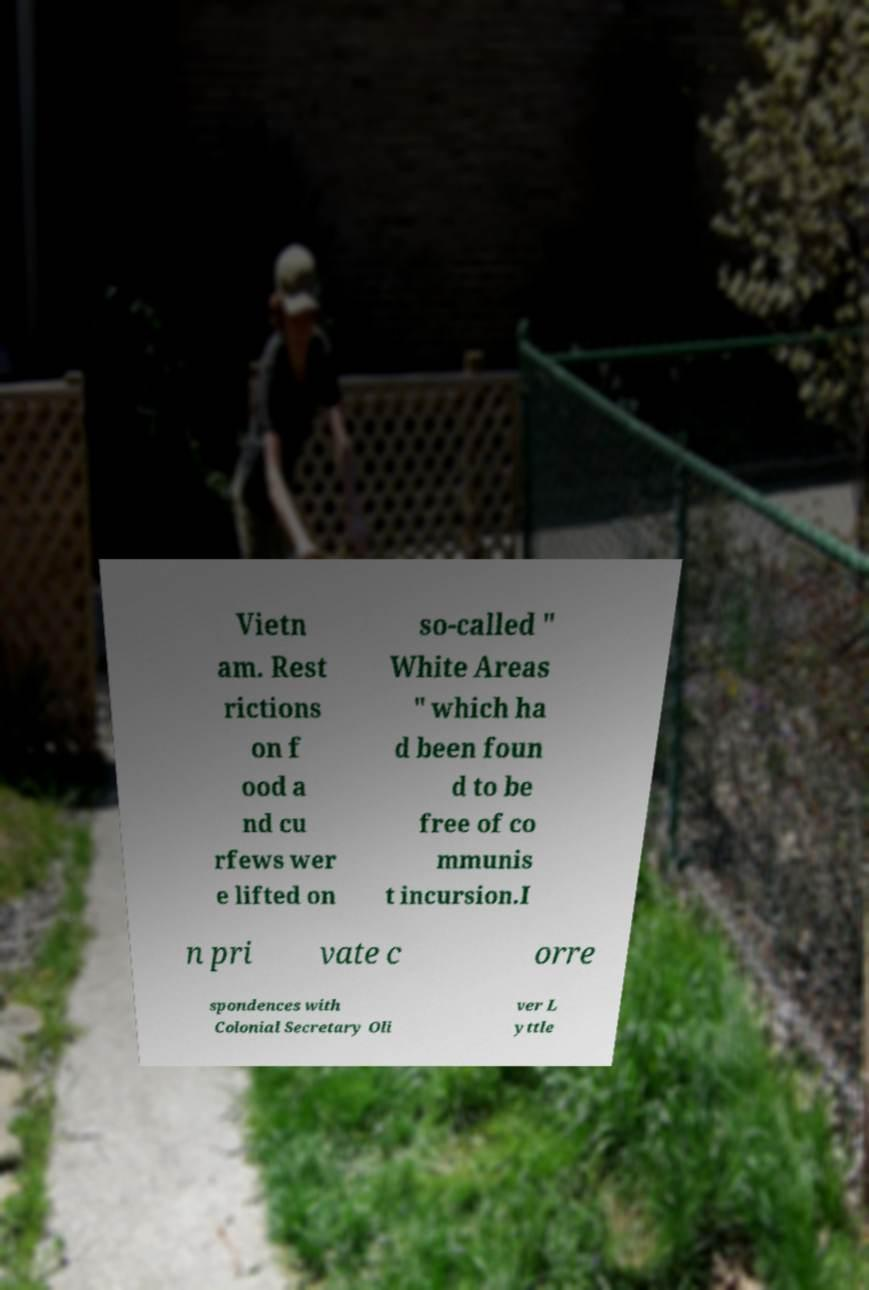There's text embedded in this image that I need extracted. Can you transcribe it verbatim? Vietn am. Rest rictions on f ood a nd cu rfews wer e lifted on so-called " White Areas " which ha d been foun d to be free of co mmunis t incursion.I n pri vate c orre spondences with Colonial Secretary Oli ver L yttle 